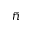<formula> <loc_0><loc_0><loc_500><loc_500>\bar { n }</formula> 